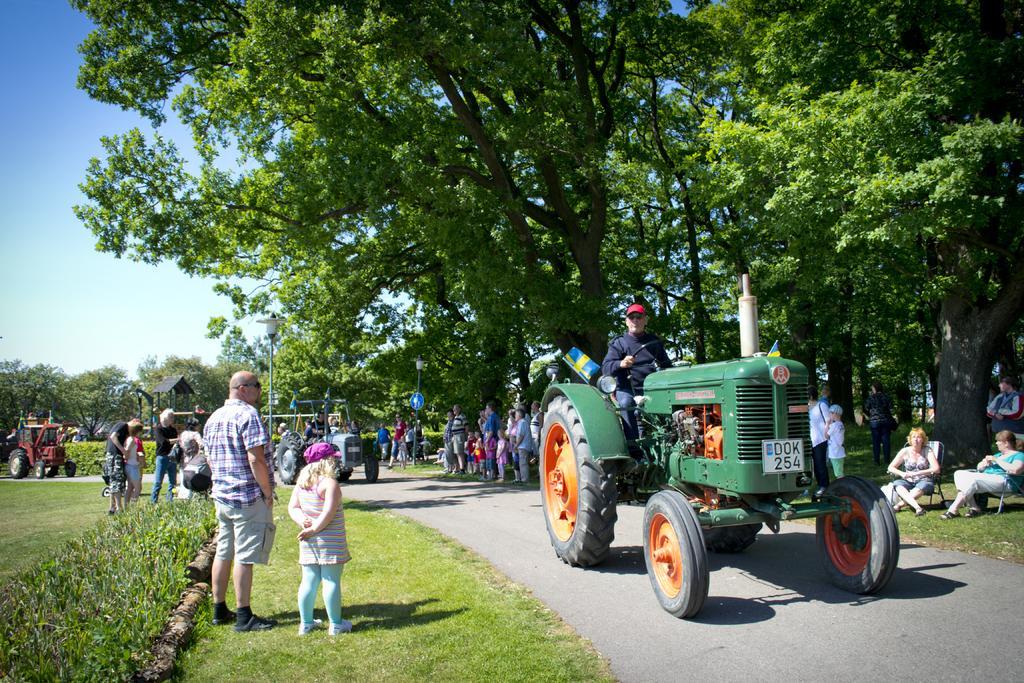Describe this image in one or two sentences. In this picture I can see there are few people standing here and there is a road here and there are trees, plants, poles and the sky is clear. 